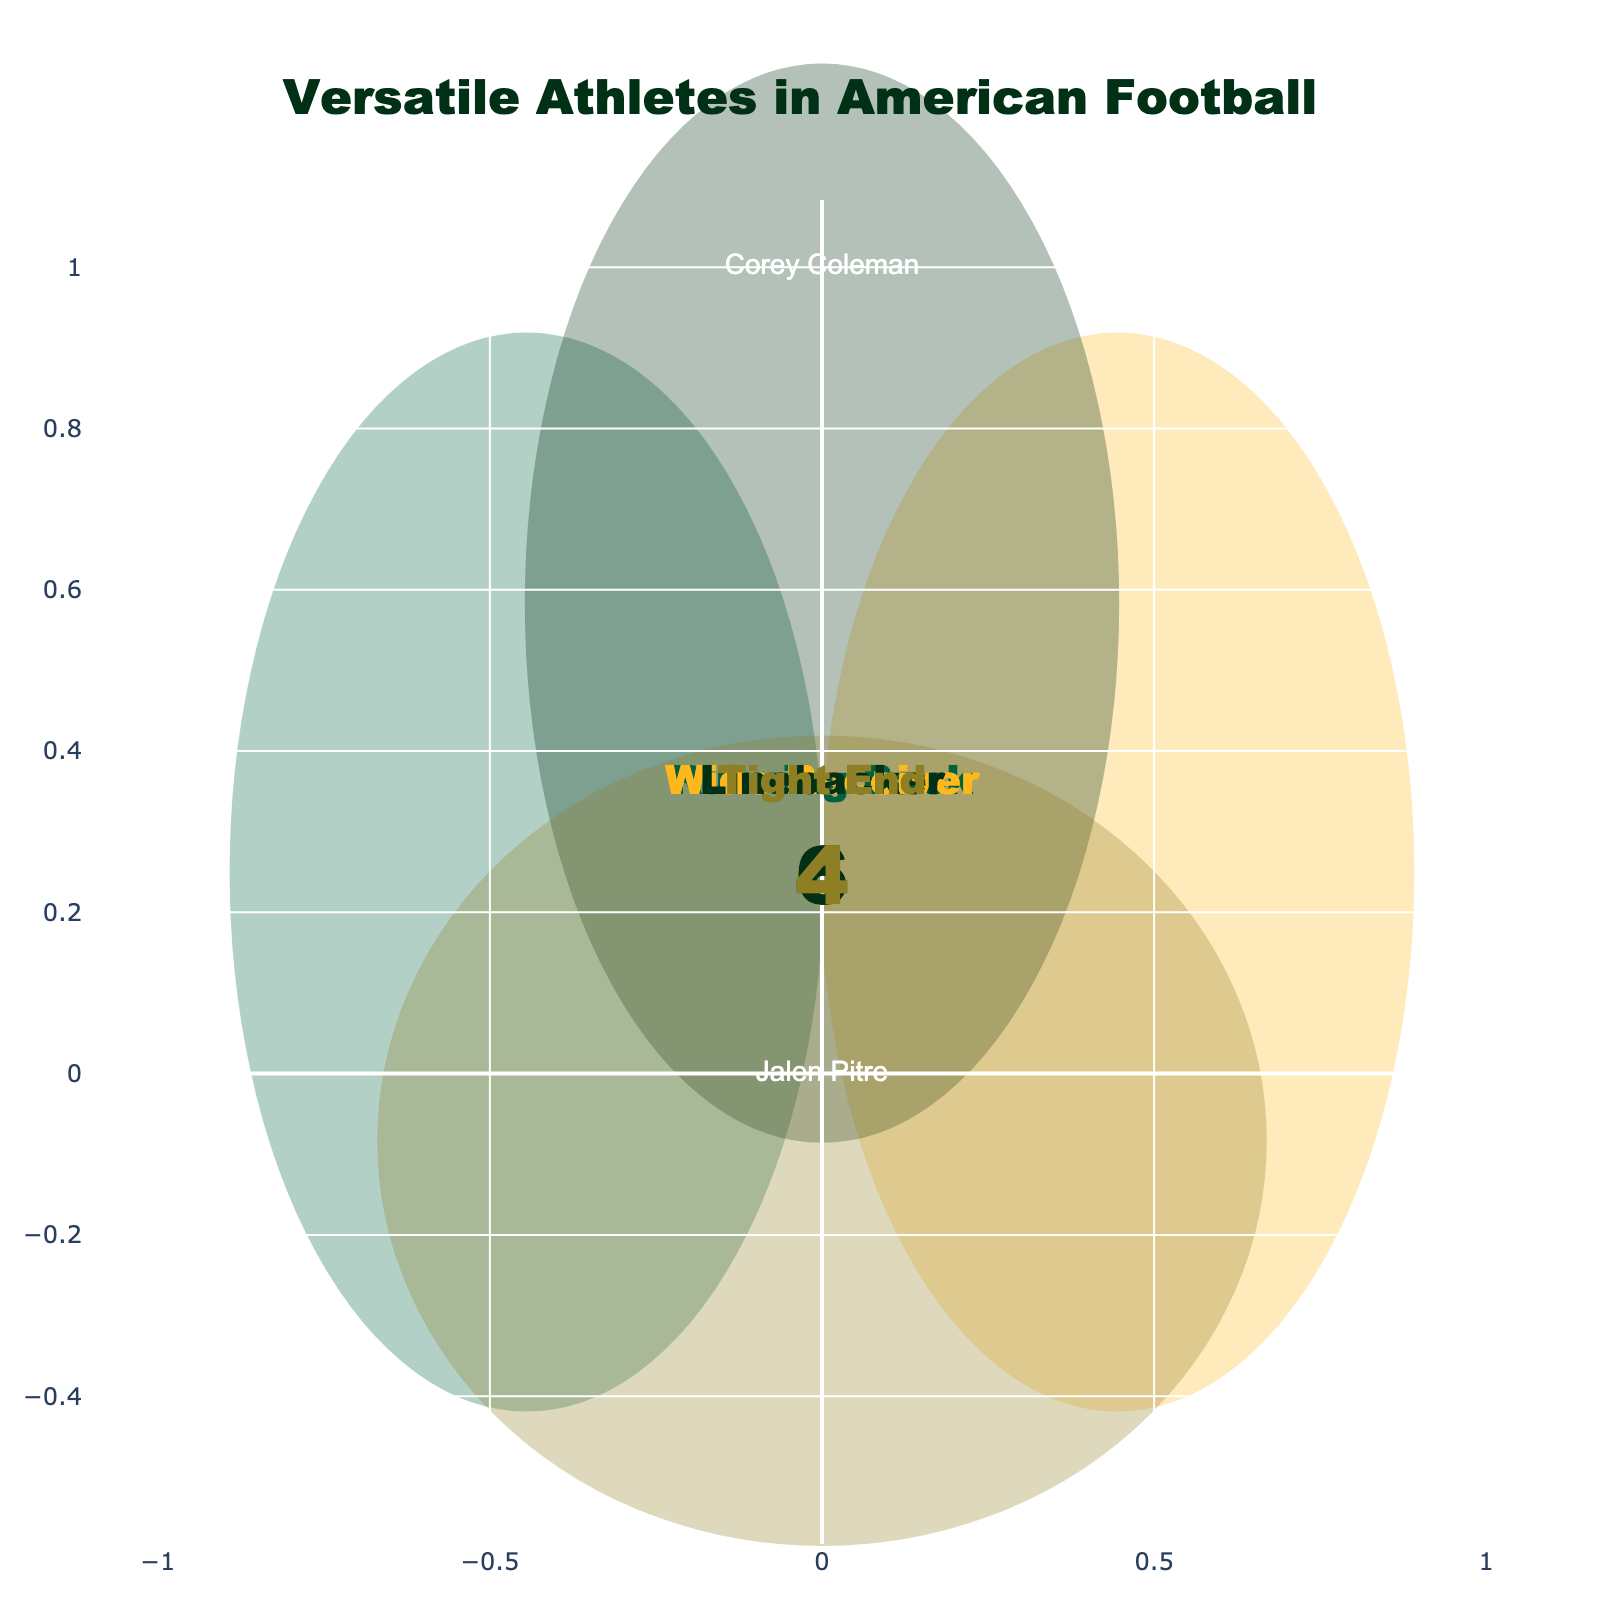What's the title of the figure? The title of the figure is generally prominently displayed near the top and provides an overall description of the chart's subject. Here, it reads "Versatile Athletes in American Football".
Answer: Versatile Athletes in American Football What color represents the 'Running Back' position? The color representation can be identified by observing the circle that corresponds to the 'Running Back' indicator. In this figure, 'Running Back' is represented by a dark green color.
Answer: Dark green How many players are depicted in the figure for the 'Wide Receiver' position only? The players who are solely playing the 'Wide Receiver' position can be found in the figure section that pertains only to 'Wide Receivers'. Here, Terrance Williams is the sole player depicted in that position only.
Answer: 1 Who is the player that overlaps all four positions? The overlapping section for all four positions will include a player if there is indeed one that fits all criteria mentioned. In this figure, there is no player covering all mentioned roles.
Answer: None What is the total number of players who can play as 'Linebacker'? Players who can play as 'Linebacker' will be counted across all segments that include the 'Linebacker' position. Here, those players are: Clay Matthews, Chuck Bednarik, Taysom Hill, Lache Seastrunk, Brian Urlacher, and Jalen Pitre, totaling 6 players.
Answer: 6 Which position has the least versatile athletes (i.e., athletes playing only that position)? To find this, examine each position's unique section. 'Tight End' and 'Wide Receiver' both have one unique player each: John Mackey and Terrance Williams. To solve this, we can compare their counts, making them equal for both.
Answer: Tight End/Wide Receiver Who is the athlete that can play both 'Tight End' and 'Linebacker' but no other positions? Examine the portion of the intersection of 'Tight End' and 'Linebacker' that excludes other positions. Here, the player that fits is Brian Urlacher.
Answer: Brian Urlacher Which overlapping section has the highest number of players? This can be observed by identifying the intersection segment that contains the maximum number of player names. 'Running Back, Wide Receiver' has the highest count here with Tevin Reese and Lache Seastrunk being part, totaling to 2 athletes.
Answer: Running Back, Wide Receiver 